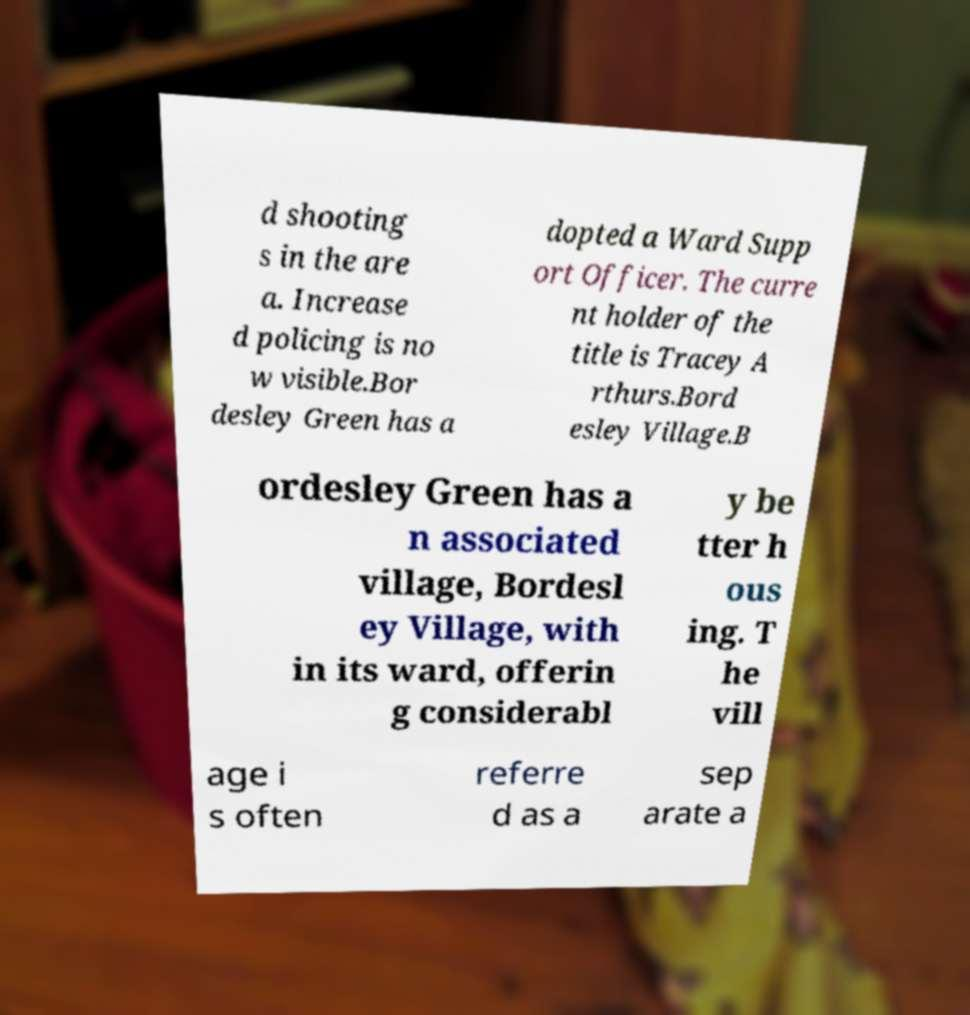Can you accurately transcribe the text from the provided image for me? d shooting s in the are a. Increase d policing is no w visible.Bor desley Green has a dopted a Ward Supp ort Officer. The curre nt holder of the title is Tracey A rthurs.Bord esley Village.B ordesley Green has a n associated village, Bordesl ey Village, with in its ward, offerin g considerabl y be tter h ous ing. T he vill age i s often referre d as a sep arate a 